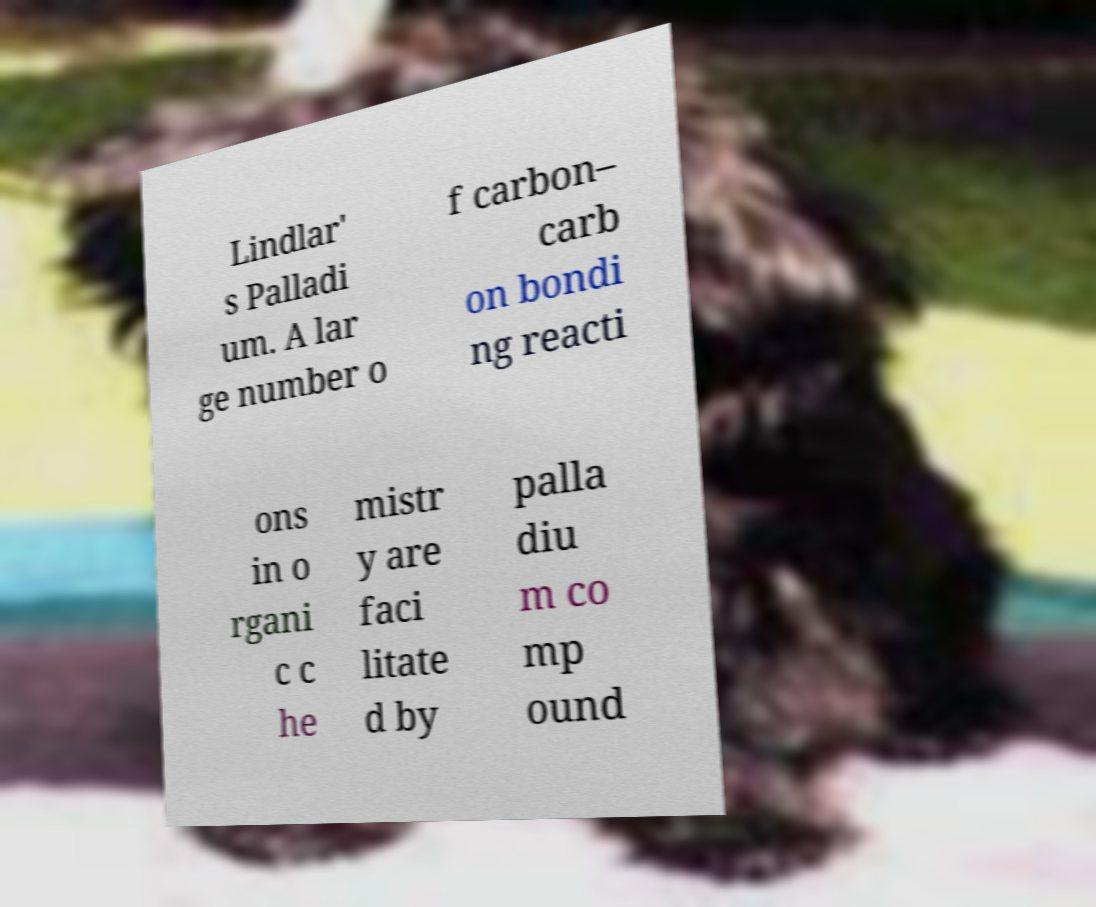For documentation purposes, I need the text within this image transcribed. Could you provide that? Lindlar' s Palladi um. A lar ge number o f carbon– carb on bondi ng reacti ons in o rgani c c he mistr y are faci litate d by palla diu m co mp ound 